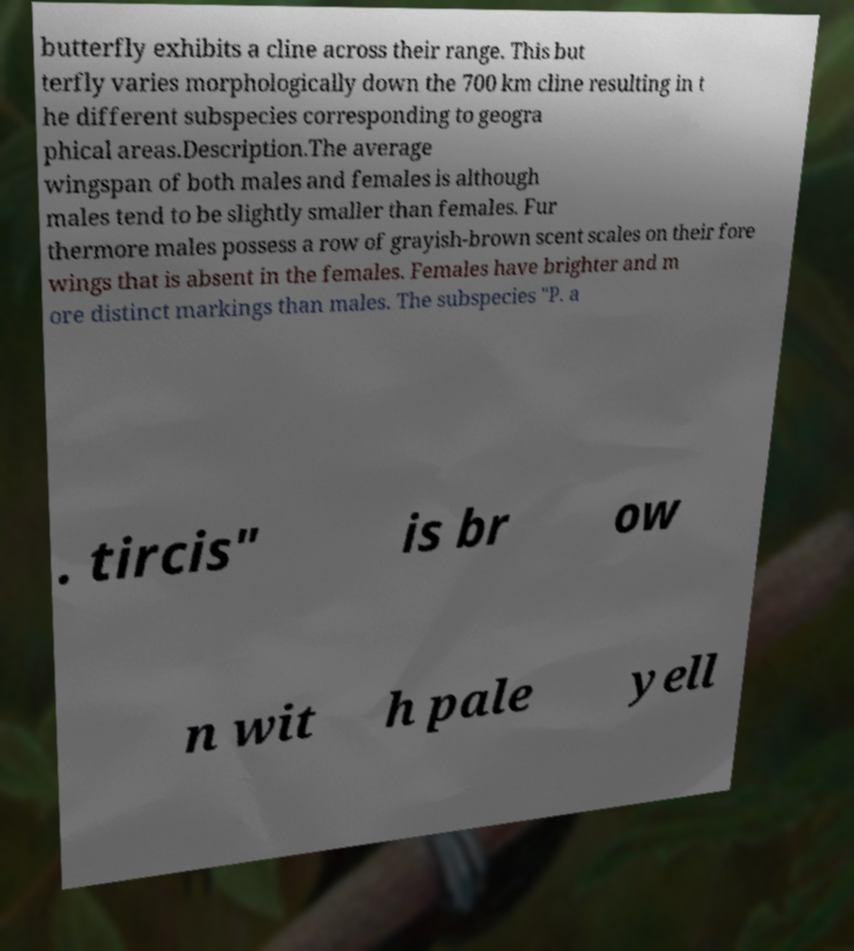There's text embedded in this image that I need extracted. Can you transcribe it verbatim? butterfly exhibits a cline across their range. This but terfly varies morphologically down the 700 km cline resulting in t he different subspecies corresponding to geogra phical areas.Description.The average wingspan of both males and females is although males tend to be slightly smaller than females. Fur thermore males possess a row of grayish-brown scent scales on their fore wings that is absent in the females. Females have brighter and m ore distinct markings than males. The subspecies "P. a . tircis" is br ow n wit h pale yell 